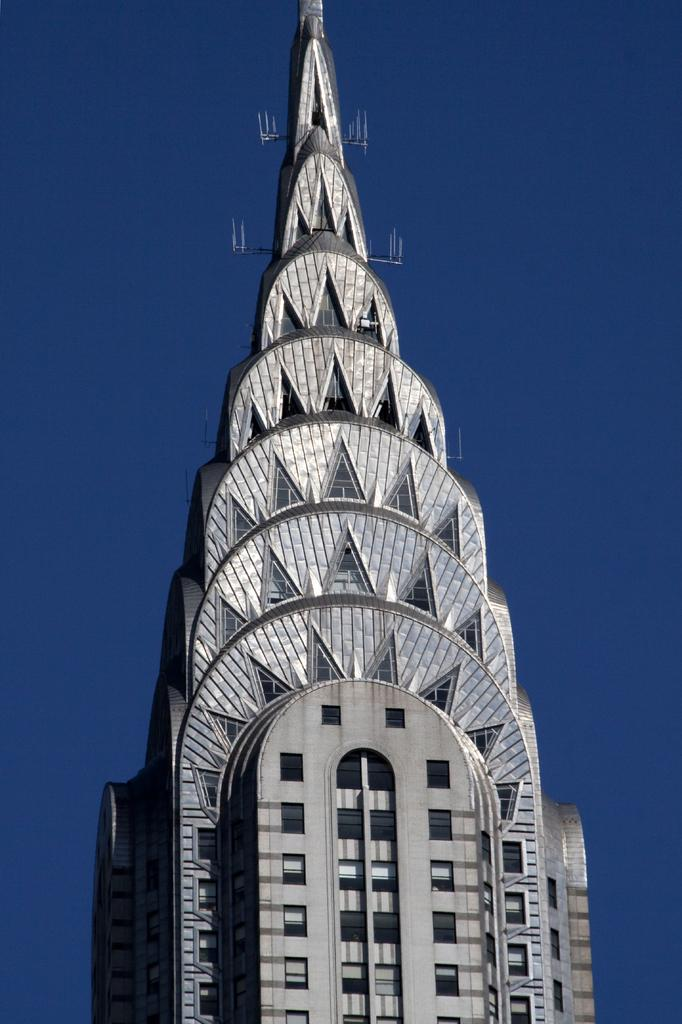What structure is present in the image? There is a building in the image. What feature of the building is mentioned in the facts? The building has many windows. What part of the natural environment is visible in the image? The sky is visible in the image. What type of machine is used for digestion in the image? There is no machine or reference to digestion present in the image. What type of toys can be seen in the image? There is no mention of toys in the image; it features a building with many windows and a visible sky. 